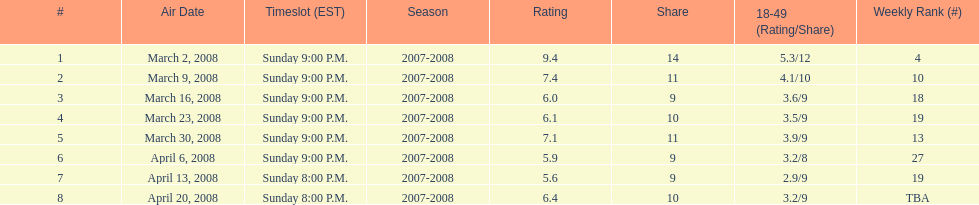How many shows had more than 10 million viewers? 4. 